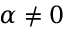Convert formula to latex. <formula><loc_0><loc_0><loc_500><loc_500>\alpha \neq 0</formula> 